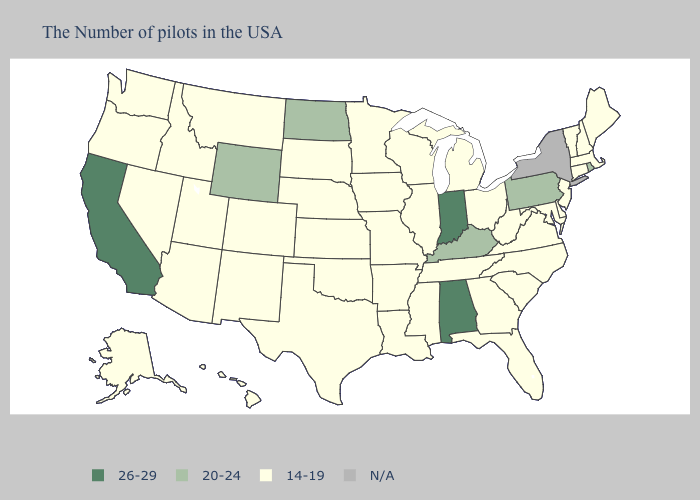Name the states that have a value in the range 26-29?
Give a very brief answer. Indiana, Alabama, California. Does Mississippi have the lowest value in the USA?
Concise answer only. Yes. What is the value of Nevada?
Write a very short answer. 14-19. What is the value of North Carolina?
Write a very short answer. 14-19. What is the value of Nebraska?
Quick response, please. 14-19. What is the value of Maryland?
Short answer required. 14-19. Name the states that have a value in the range N/A?
Answer briefly. New York. Name the states that have a value in the range 20-24?
Short answer required. Rhode Island, Pennsylvania, Kentucky, North Dakota, Wyoming. Is the legend a continuous bar?
Answer briefly. No. Among the states that border Idaho , does Wyoming have the highest value?
Be succinct. Yes. Does the first symbol in the legend represent the smallest category?
Concise answer only. No. Which states have the lowest value in the MidWest?
Answer briefly. Ohio, Michigan, Wisconsin, Illinois, Missouri, Minnesota, Iowa, Kansas, Nebraska, South Dakota. What is the value of North Dakota?
Answer briefly. 20-24. 